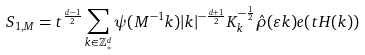<formula> <loc_0><loc_0><loc_500><loc_500>S _ { 1 , M } = t ^ { \frac { d - 1 } { 2 } } \sum _ { k \in \mathbb { Z } _ { * } ^ { d } } \psi ( M ^ { - 1 } k ) | k | ^ { - \frac { d + 1 } { 2 } } K _ { k } ^ { - \frac { 1 } { 2 } } \hat { \rho } ( \varepsilon k ) e ( t H ( k ) )</formula> 